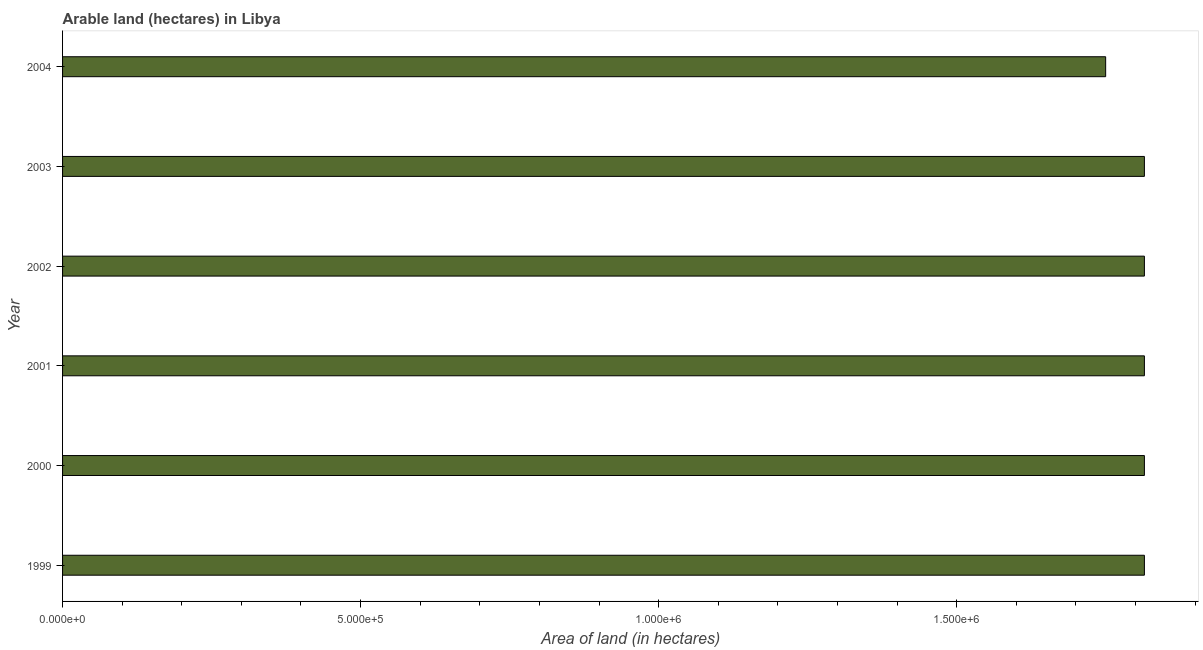What is the title of the graph?
Your answer should be compact. Arable land (hectares) in Libya. What is the label or title of the X-axis?
Provide a succinct answer. Area of land (in hectares). What is the area of land in 2004?
Provide a succinct answer. 1.75e+06. Across all years, what is the maximum area of land?
Your response must be concise. 1.82e+06. Across all years, what is the minimum area of land?
Offer a very short reply. 1.75e+06. In which year was the area of land maximum?
Keep it short and to the point. 1999. What is the sum of the area of land?
Your answer should be compact. 1.08e+07. What is the average area of land per year?
Make the answer very short. 1.80e+06. What is the median area of land?
Your response must be concise. 1.82e+06. In how many years, is the area of land greater than 200000 hectares?
Give a very brief answer. 6. Do a majority of the years between 2000 and 2001 (inclusive) have area of land greater than 100000 hectares?
Keep it short and to the point. Yes. What is the ratio of the area of land in 2001 to that in 2003?
Your response must be concise. 1. Is the difference between the area of land in 1999 and 2000 greater than the difference between any two years?
Provide a short and direct response. No. What is the difference between the highest and the second highest area of land?
Keep it short and to the point. 0. What is the difference between the highest and the lowest area of land?
Offer a terse response. 6.50e+04. Are the values on the major ticks of X-axis written in scientific E-notation?
Give a very brief answer. Yes. What is the Area of land (in hectares) of 1999?
Give a very brief answer. 1.82e+06. What is the Area of land (in hectares) of 2000?
Your answer should be compact. 1.82e+06. What is the Area of land (in hectares) in 2001?
Offer a terse response. 1.82e+06. What is the Area of land (in hectares) in 2002?
Your answer should be very brief. 1.82e+06. What is the Area of land (in hectares) of 2003?
Provide a short and direct response. 1.82e+06. What is the Area of land (in hectares) in 2004?
Your answer should be compact. 1.75e+06. What is the difference between the Area of land (in hectares) in 1999 and 2000?
Offer a terse response. 0. What is the difference between the Area of land (in hectares) in 1999 and 2002?
Provide a short and direct response. 0. What is the difference between the Area of land (in hectares) in 1999 and 2003?
Your answer should be very brief. 0. What is the difference between the Area of land (in hectares) in 1999 and 2004?
Provide a succinct answer. 6.50e+04. What is the difference between the Area of land (in hectares) in 2000 and 2001?
Provide a succinct answer. 0. What is the difference between the Area of land (in hectares) in 2000 and 2003?
Your answer should be very brief. 0. What is the difference between the Area of land (in hectares) in 2000 and 2004?
Provide a short and direct response. 6.50e+04. What is the difference between the Area of land (in hectares) in 2001 and 2002?
Your answer should be very brief. 0. What is the difference between the Area of land (in hectares) in 2001 and 2004?
Ensure brevity in your answer.  6.50e+04. What is the difference between the Area of land (in hectares) in 2002 and 2004?
Keep it short and to the point. 6.50e+04. What is the difference between the Area of land (in hectares) in 2003 and 2004?
Your answer should be compact. 6.50e+04. What is the ratio of the Area of land (in hectares) in 1999 to that in 2002?
Ensure brevity in your answer.  1. What is the ratio of the Area of land (in hectares) in 1999 to that in 2004?
Provide a short and direct response. 1.04. What is the ratio of the Area of land (in hectares) in 2000 to that in 2001?
Make the answer very short. 1. What is the ratio of the Area of land (in hectares) in 2000 to that in 2002?
Offer a very short reply. 1. What is the ratio of the Area of land (in hectares) in 2001 to that in 2002?
Offer a very short reply. 1. What is the ratio of the Area of land (in hectares) in 2001 to that in 2003?
Give a very brief answer. 1. What is the ratio of the Area of land (in hectares) in 2001 to that in 2004?
Keep it short and to the point. 1.04. What is the ratio of the Area of land (in hectares) in 2002 to that in 2004?
Offer a terse response. 1.04. 